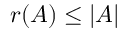Convert formula to latex. <formula><loc_0><loc_0><loc_500><loc_500>r ( A ) \leq | A |</formula> 